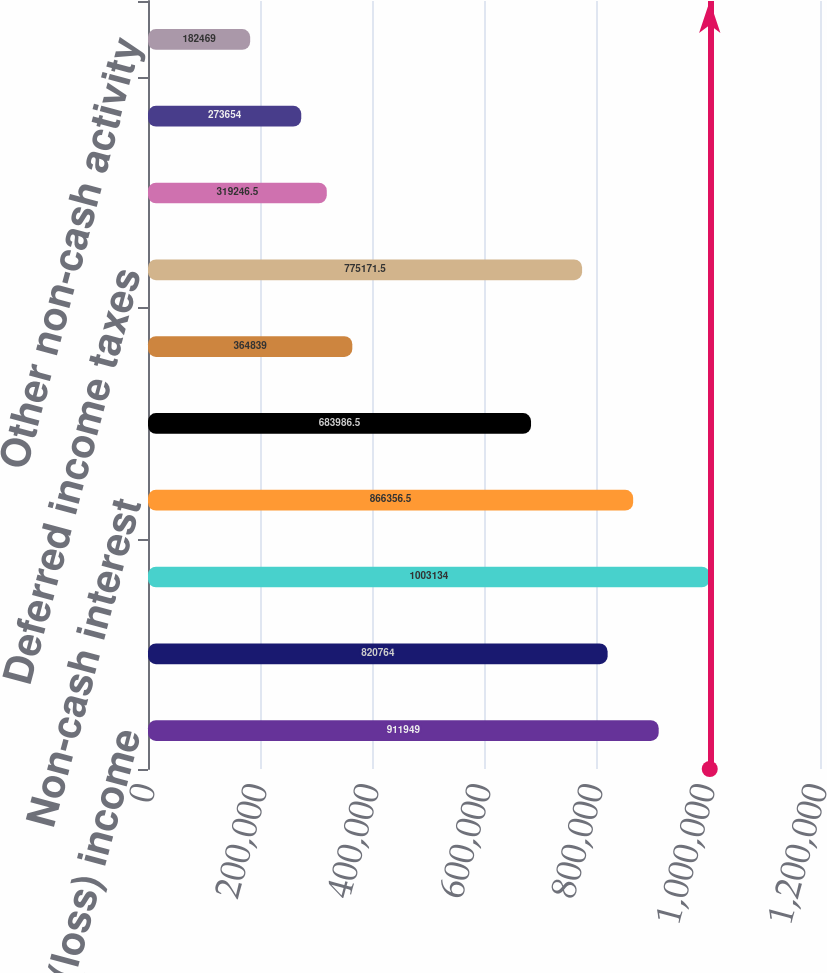Convert chart. <chart><loc_0><loc_0><loc_500><loc_500><bar_chart><fcel>Net (loss) income<fcel>Depreciation<fcel>Amortization<fcel>Non-cash interest<fcel>Stock-based compensation<fcel>Excess tax benefit related to<fcel>Deferred income taxes<fcel>Fair value write-up of<fcel>Loss on disposal of property<fcel>Other non-cash activity<nl><fcel>911949<fcel>820764<fcel>1.00313e+06<fcel>866356<fcel>683986<fcel>364839<fcel>775172<fcel>319246<fcel>273654<fcel>182469<nl></chart> 